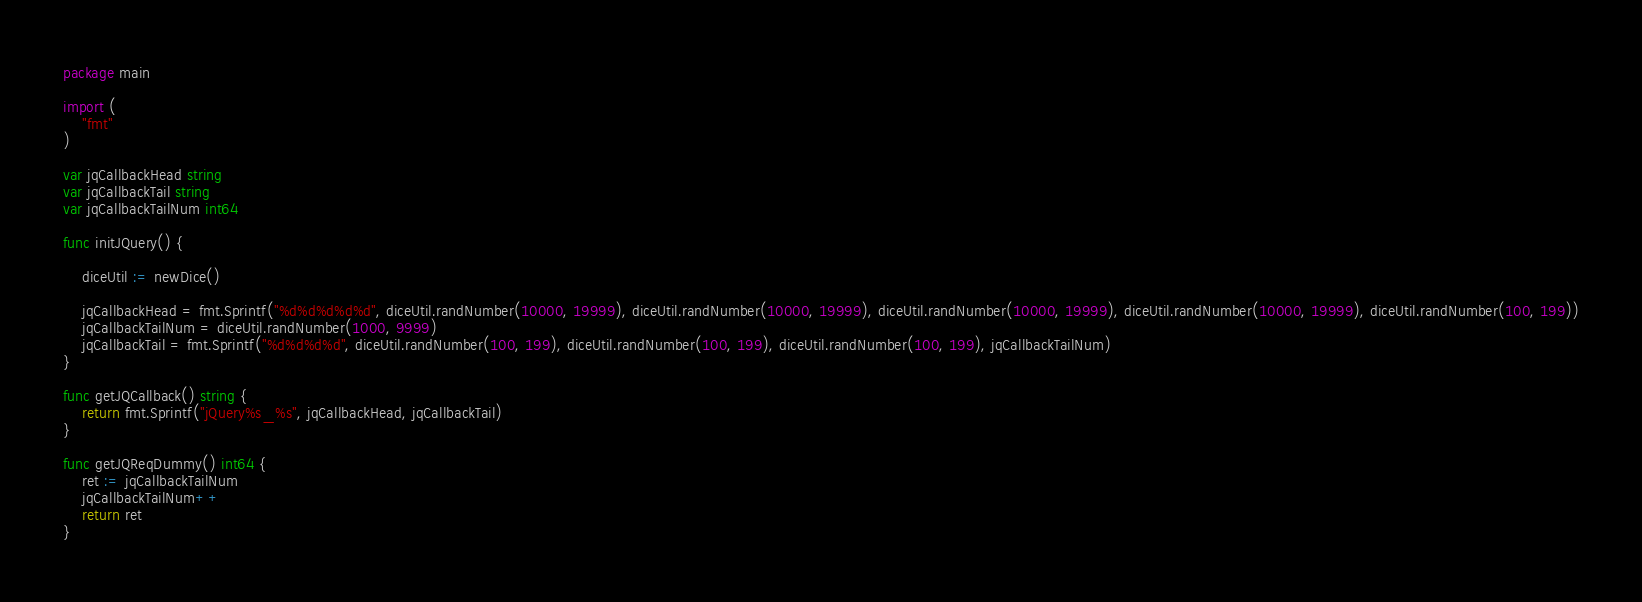<code> <loc_0><loc_0><loc_500><loc_500><_Go_>package main

import (
	"fmt"
)

var jqCallbackHead string
var jqCallbackTail string
var jqCallbackTailNum int64

func initJQuery() {

	diceUtil := newDice()

	jqCallbackHead = fmt.Sprintf("%d%d%d%d%d", diceUtil.randNumber(10000, 19999), diceUtil.randNumber(10000, 19999), diceUtil.randNumber(10000, 19999), diceUtil.randNumber(10000, 19999), diceUtil.randNumber(100, 199))
	jqCallbackTailNum = diceUtil.randNumber(1000, 9999)
	jqCallbackTail = fmt.Sprintf("%d%d%d%d", diceUtil.randNumber(100, 199), diceUtil.randNumber(100, 199), diceUtil.randNumber(100, 199), jqCallbackTailNum)
}

func getJQCallback() string {
	return fmt.Sprintf("jQuery%s_%s", jqCallbackHead, jqCallbackTail)
}

func getJQReqDummy() int64 {
	ret := jqCallbackTailNum
	jqCallbackTailNum++
	return ret
}
</code> 